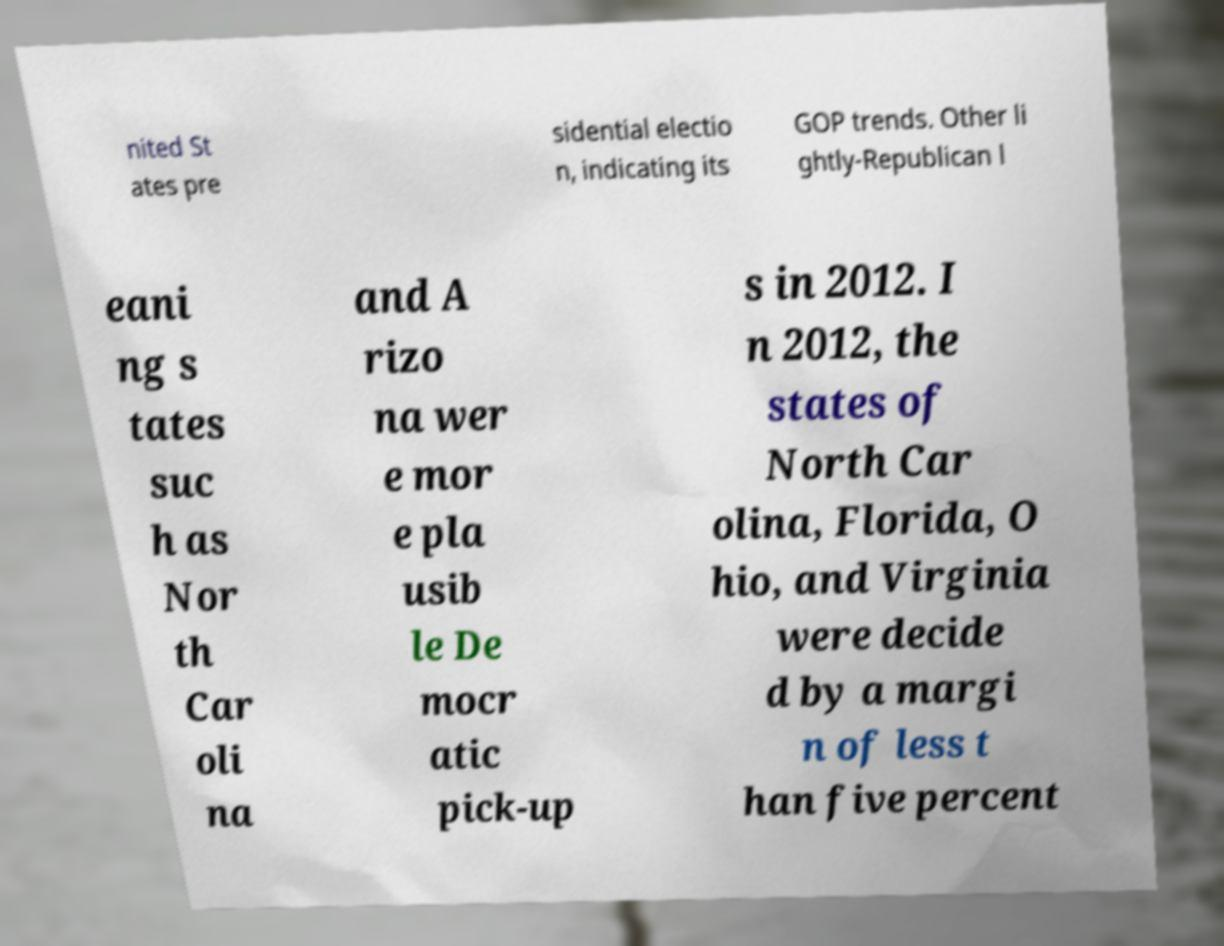Can you read and provide the text displayed in the image?This photo seems to have some interesting text. Can you extract and type it out for me? nited St ates pre sidential electio n, indicating its GOP trends. Other li ghtly-Republican l eani ng s tates suc h as Nor th Car oli na and A rizo na wer e mor e pla usib le De mocr atic pick-up s in 2012. I n 2012, the states of North Car olina, Florida, O hio, and Virginia were decide d by a margi n of less t han five percent 